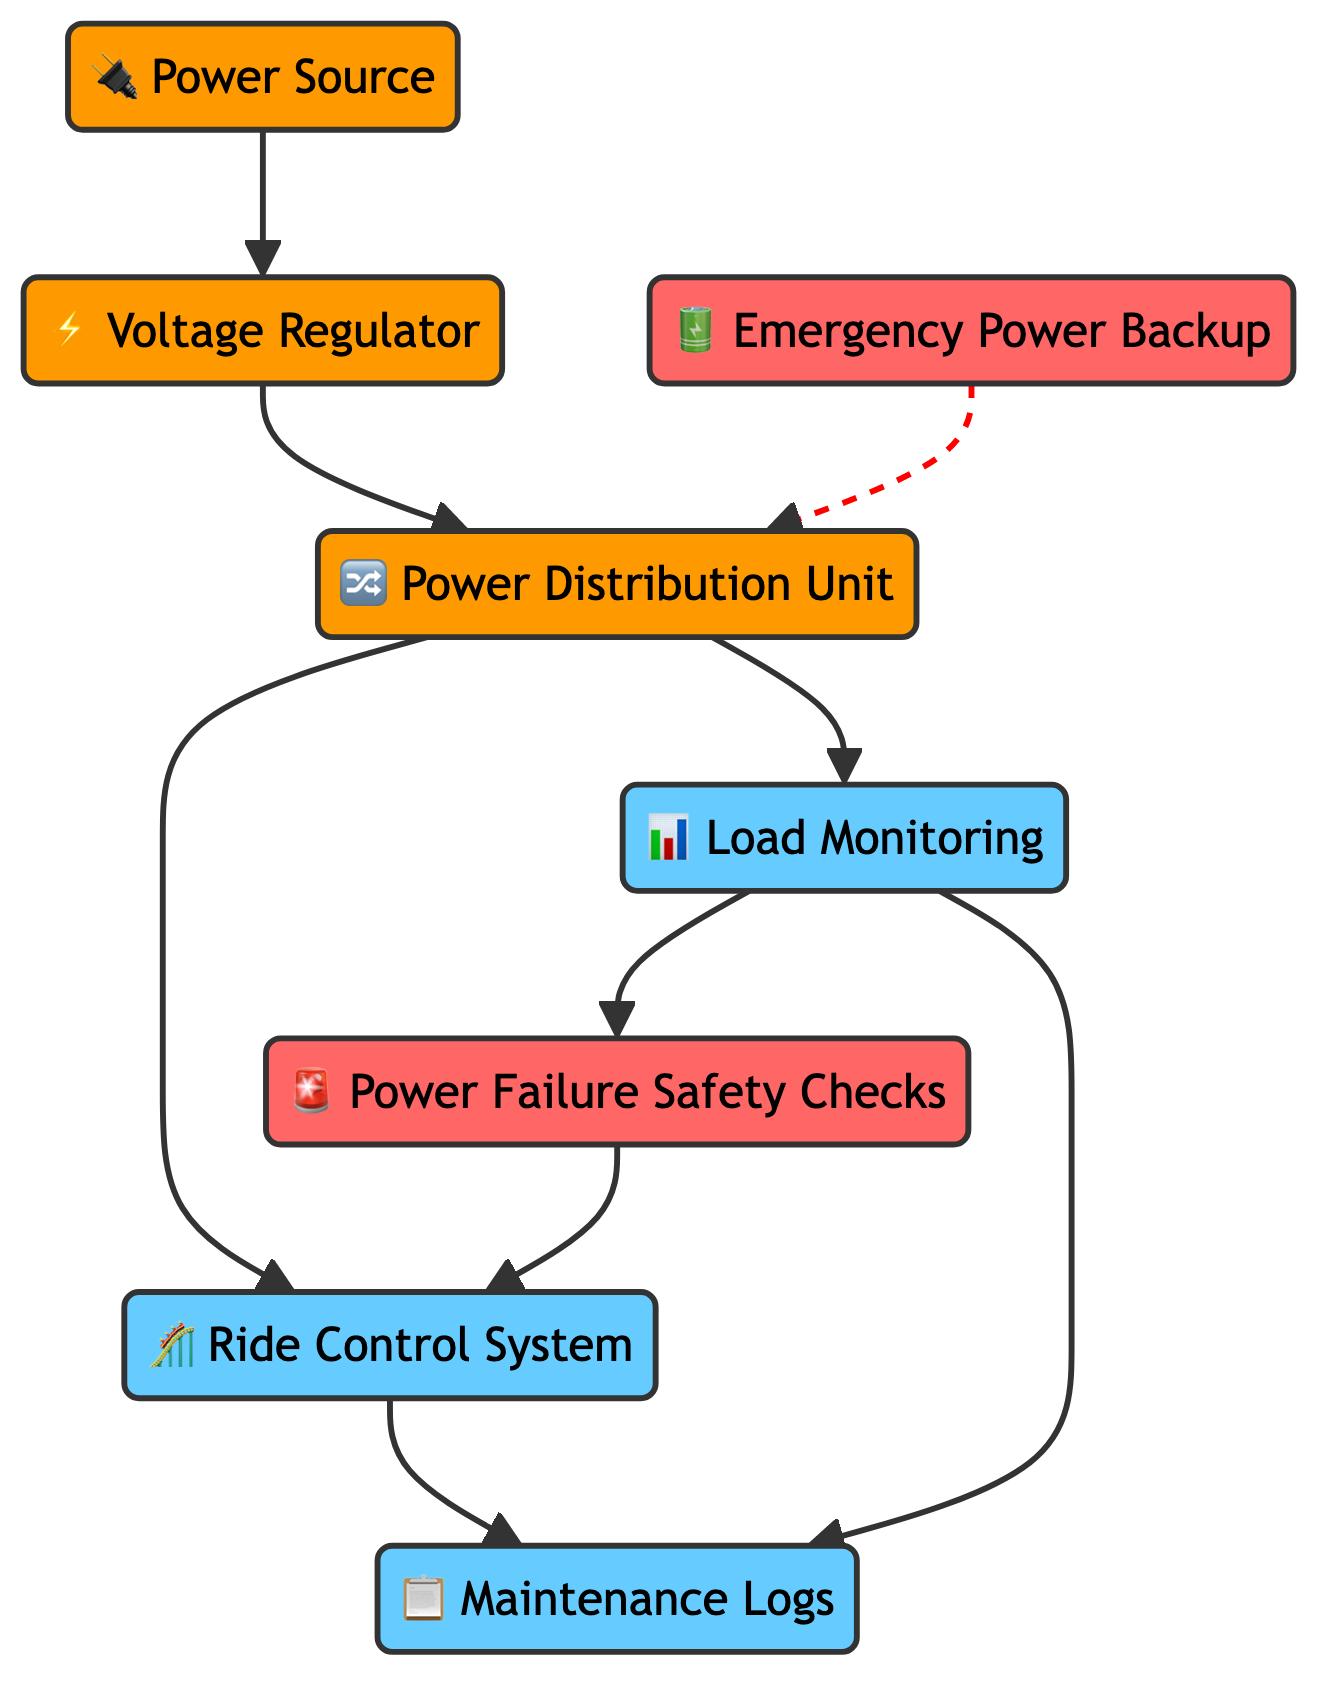What is the primary input for the power management process? The diagram indicates 'Power Source' as the primary input, which is the beginning node connected to other components like Voltage Regulator.
Answer: Power Source How many nodes are present in the diagram? Counting all unique elements in the diagram, there are a total of 8 nodes: Power Source, Voltage Regulator, Power Distribution Unit, Ride Control System, Emergency Power Backup, Load Monitoring, Power Failure Safety Checks, and Maintenance Logs.
Answer: 8 What is the role of the Voltage Regulator? The Voltage Regulator ensures stable voltage output, as described in the diagram. It is the first component in the process that leads to power distribution.
Answer: Stable voltage output Which nodes are directly connected to the Power Distribution Unit? The diagram shows that the Power Distribution Unit is directly connected to the Ride Control System and Load Monitoring. These are the outputs of the power distribution process.
Answer: Ride Control System, Load Monitoring What is engaged during power outages according to the diagram? The diagram specifies that 'Power Failure Safety Checks' are automatically engaged during power outages, serving as a safety mechanism.
Answer: Power Failure Safety Checks How does Load Monitoring interact with the Ride Control System? Load Monitoring tracks the electrical load and is directly connected to the Power Failure Safety Checks, which subsequently informs the Ride Control System, thus ensuring safety and operation integrity.
Answer: Ensures safety What function does the Emergency Power Backup serve? According to the diagram, the Emergency Power Backup is described as an uninterruptible power supply for emergency situations, providing critical power when main sources fail.
Answer: Emergency situations How does the Maintenance Logs connect to the other components? The Maintenance Logs are connected to both the Ride Control System and Load Monitoring, indicating that logging is informed by both ride operations and electrical load monitoring for safety and records.
Answer: Ride Control System, Load Monitoring 